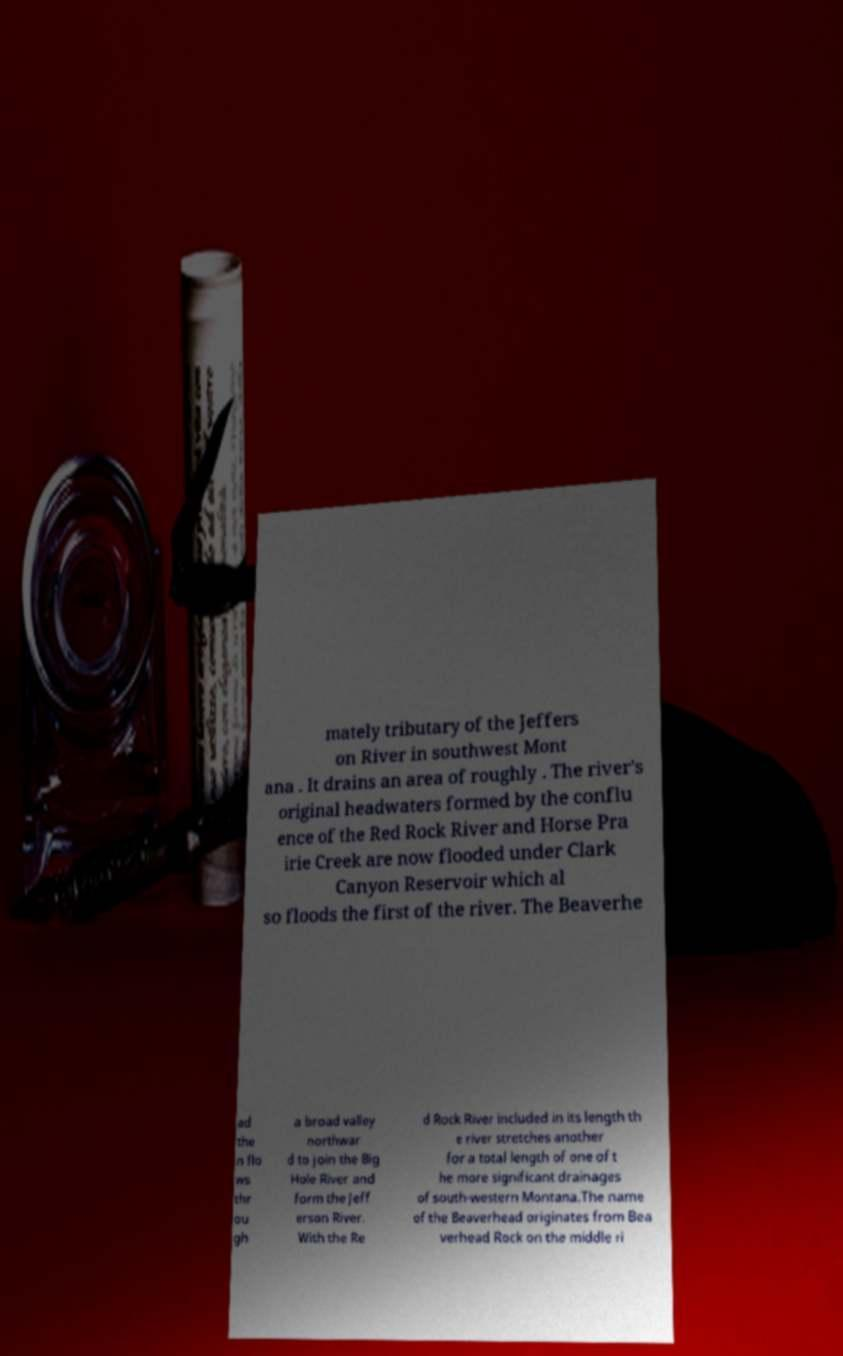What messages or text are displayed in this image? I need them in a readable, typed format. mately tributary of the Jeffers on River in southwest Mont ana . It drains an area of roughly . The river's original headwaters formed by the conflu ence of the Red Rock River and Horse Pra irie Creek are now flooded under Clark Canyon Reservoir which al so floods the first of the river. The Beaverhe ad the n flo ws thr ou gh a broad valley northwar d to join the Big Hole River and form the Jeff erson River. With the Re d Rock River included in its length th e river stretches another for a total length of one of t he more significant drainages of south-western Montana.The name of the Beaverhead originates from Bea verhead Rock on the middle ri 